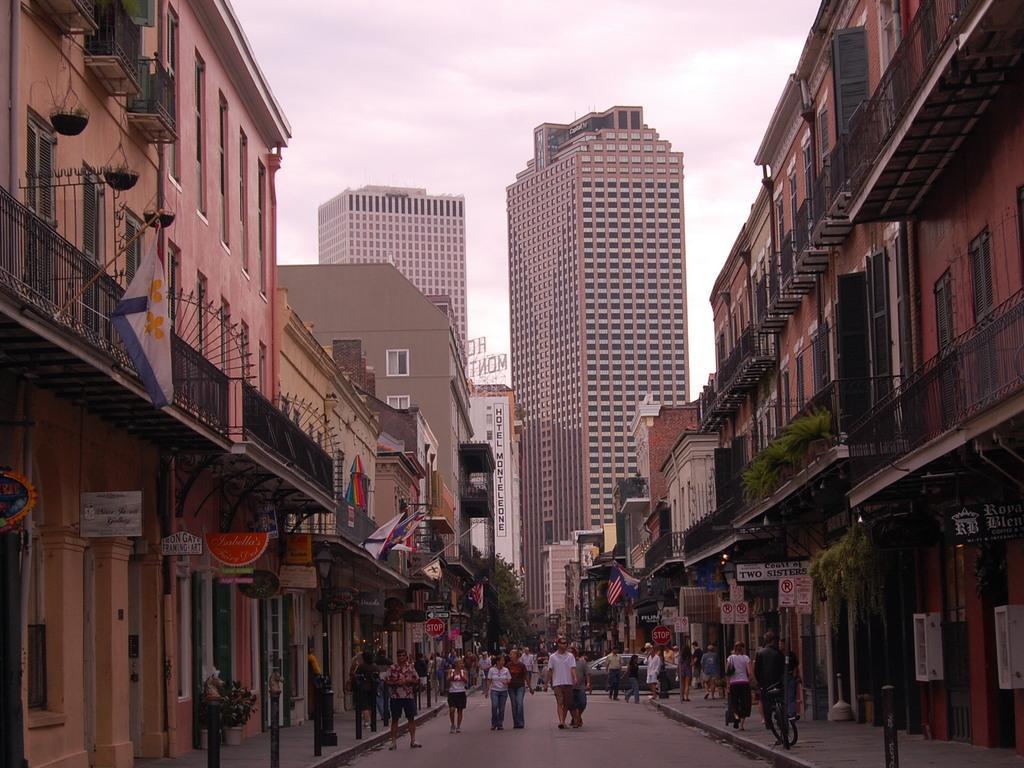Can you describe this image briefly? In this image I can see few people are standing on the road. These people are wearing the different color dresses. To the side of the people I can see many buildings, poles and some boards to it. In the back I can see few more buildings and the white sky. 